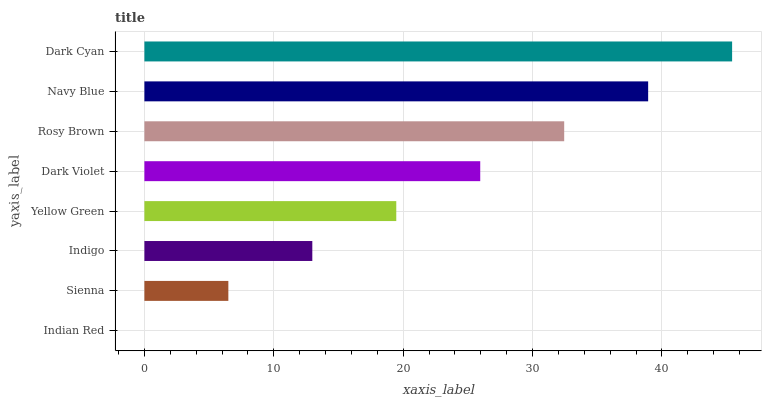Is Indian Red the minimum?
Answer yes or no. Yes. Is Dark Cyan the maximum?
Answer yes or no. Yes. Is Sienna the minimum?
Answer yes or no. No. Is Sienna the maximum?
Answer yes or no. No. Is Sienna greater than Indian Red?
Answer yes or no. Yes. Is Indian Red less than Sienna?
Answer yes or no. Yes. Is Indian Red greater than Sienna?
Answer yes or no. No. Is Sienna less than Indian Red?
Answer yes or no. No. Is Dark Violet the high median?
Answer yes or no. Yes. Is Yellow Green the low median?
Answer yes or no. Yes. Is Sienna the high median?
Answer yes or no. No. Is Navy Blue the low median?
Answer yes or no. No. 